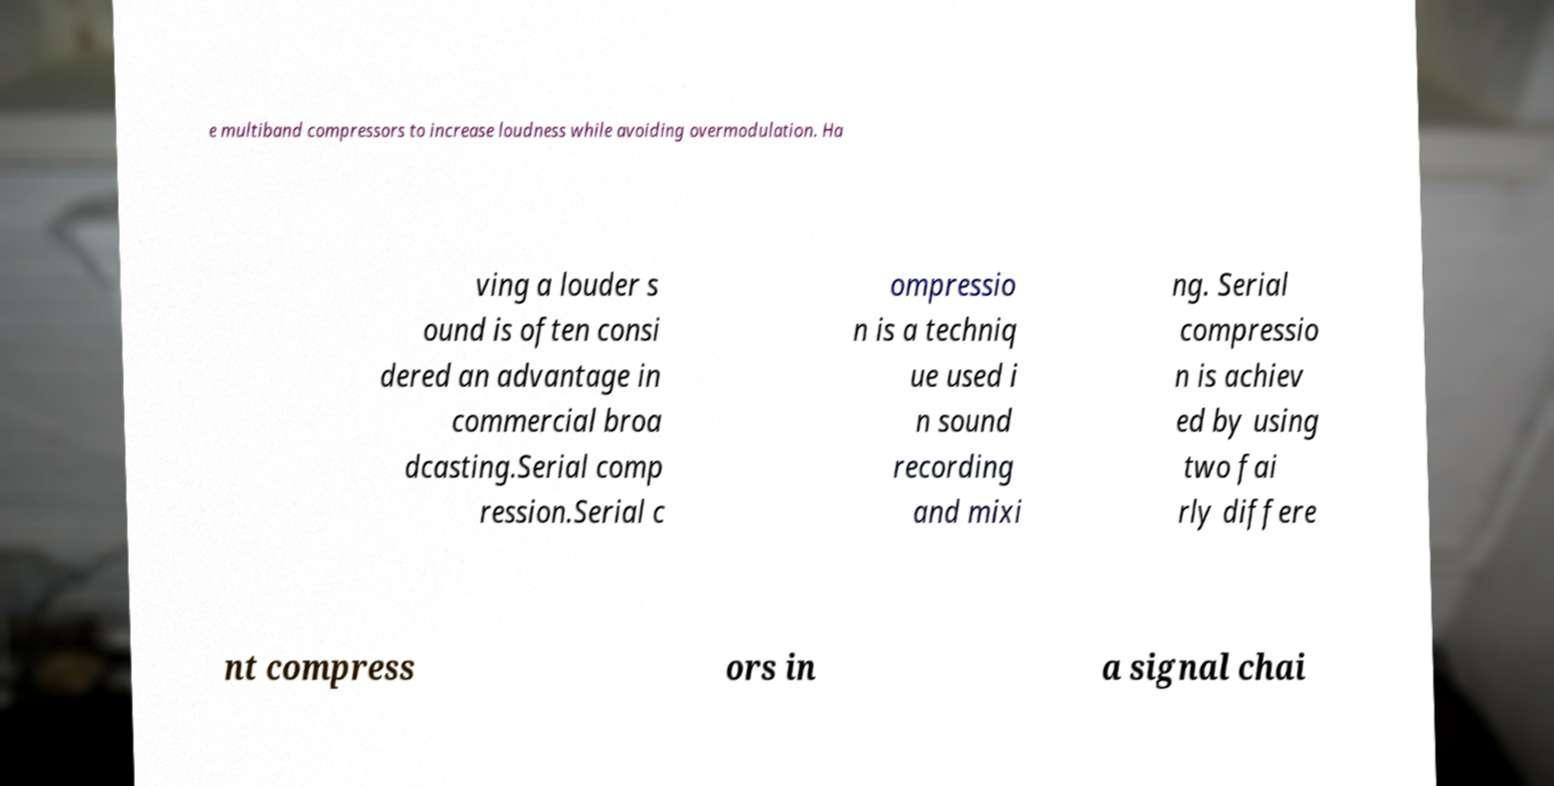Could you assist in decoding the text presented in this image and type it out clearly? e multiband compressors to increase loudness while avoiding overmodulation. Ha ving a louder s ound is often consi dered an advantage in commercial broa dcasting.Serial comp ression.Serial c ompressio n is a techniq ue used i n sound recording and mixi ng. Serial compressio n is achiev ed by using two fai rly differe nt compress ors in a signal chai 